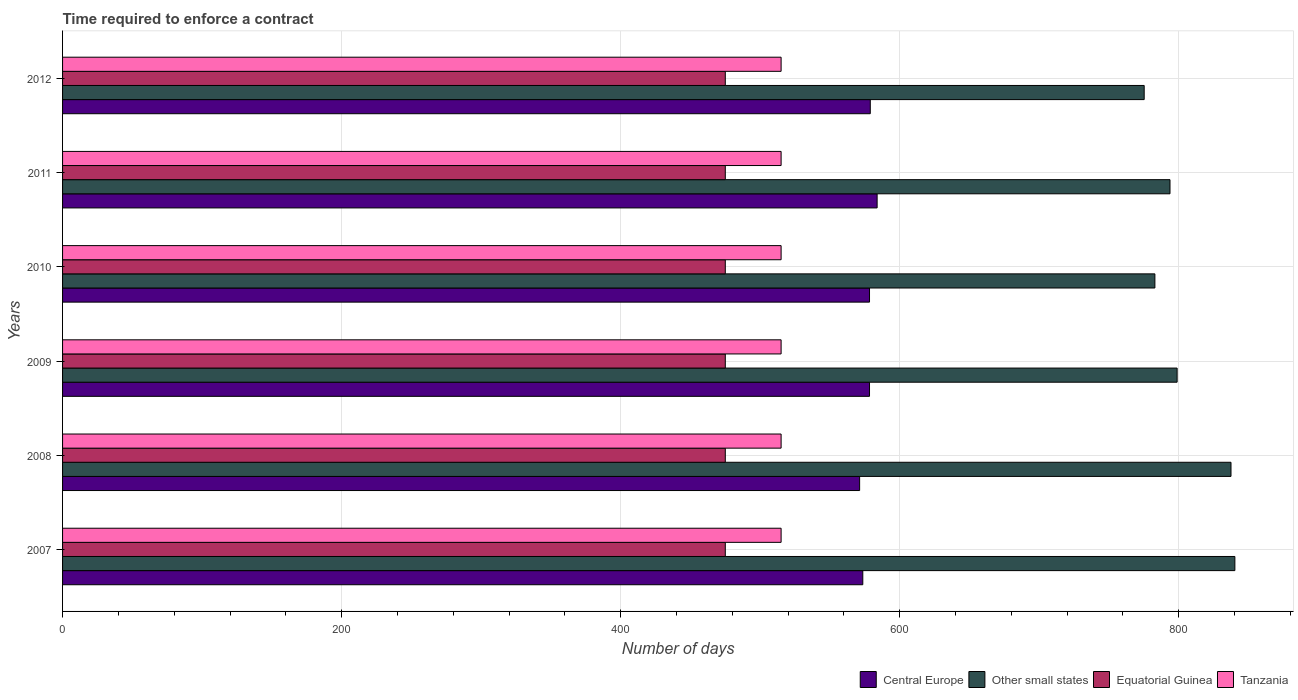How many bars are there on the 2nd tick from the bottom?
Your answer should be compact. 4. In how many cases, is the number of bars for a given year not equal to the number of legend labels?
Your answer should be compact. 0. What is the number of days required to enforce a contract in Central Europe in 2009?
Offer a terse response. 578.36. Across all years, what is the maximum number of days required to enforce a contract in Central Europe?
Provide a short and direct response. 583.82. Across all years, what is the minimum number of days required to enforce a contract in Other small states?
Offer a terse response. 775.22. What is the total number of days required to enforce a contract in Central Europe in the graph?
Your answer should be very brief. 3464.27. What is the difference between the number of days required to enforce a contract in Tanzania in 2009 and that in 2010?
Offer a terse response. 0. What is the difference between the number of days required to enforce a contract in Central Europe in 2010 and the number of days required to enforce a contract in Other small states in 2007?
Make the answer very short. -261.86. What is the average number of days required to enforce a contract in Central Europe per year?
Ensure brevity in your answer.  577.38. In the year 2009, what is the difference between the number of days required to enforce a contract in Central Europe and number of days required to enforce a contract in Equatorial Guinea?
Offer a very short reply. 103.36. In how many years, is the number of days required to enforce a contract in Central Europe greater than 520 days?
Give a very brief answer. 6. What is the ratio of the number of days required to enforce a contract in Other small states in 2007 to that in 2011?
Provide a succinct answer. 1.06. Is the number of days required to enforce a contract in Central Europe in 2008 less than that in 2012?
Keep it short and to the point. Yes. Is the difference between the number of days required to enforce a contract in Central Europe in 2011 and 2012 greater than the difference between the number of days required to enforce a contract in Equatorial Guinea in 2011 and 2012?
Provide a short and direct response. Yes. In how many years, is the number of days required to enforce a contract in Central Europe greater than the average number of days required to enforce a contract in Central Europe taken over all years?
Give a very brief answer. 4. What does the 1st bar from the top in 2009 represents?
Offer a very short reply. Tanzania. What does the 1st bar from the bottom in 2008 represents?
Make the answer very short. Central Europe. Is it the case that in every year, the sum of the number of days required to enforce a contract in Tanzania and number of days required to enforce a contract in Other small states is greater than the number of days required to enforce a contract in Central Europe?
Keep it short and to the point. Yes. How many bars are there?
Keep it short and to the point. 24. How many years are there in the graph?
Your answer should be compact. 6. Are the values on the major ticks of X-axis written in scientific E-notation?
Ensure brevity in your answer.  No. Does the graph contain grids?
Your answer should be compact. Yes. How many legend labels are there?
Provide a short and direct response. 4. What is the title of the graph?
Your response must be concise. Time required to enforce a contract. What is the label or title of the X-axis?
Provide a succinct answer. Number of days. What is the Number of days of Central Europe in 2007?
Keep it short and to the point. 573.55. What is the Number of days of Other small states in 2007?
Offer a terse response. 840.22. What is the Number of days of Equatorial Guinea in 2007?
Your answer should be compact. 475. What is the Number of days of Tanzania in 2007?
Provide a short and direct response. 515. What is the Number of days in Central Europe in 2008?
Ensure brevity in your answer.  571.27. What is the Number of days in Other small states in 2008?
Offer a very short reply. 837.44. What is the Number of days of Equatorial Guinea in 2008?
Make the answer very short. 475. What is the Number of days in Tanzania in 2008?
Provide a succinct answer. 515. What is the Number of days of Central Europe in 2009?
Ensure brevity in your answer.  578.36. What is the Number of days in Other small states in 2009?
Offer a very short reply. 798.83. What is the Number of days in Equatorial Guinea in 2009?
Your answer should be very brief. 475. What is the Number of days of Tanzania in 2009?
Your response must be concise. 515. What is the Number of days in Central Europe in 2010?
Ensure brevity in your answer.  578.36. What is the Number of days of Other small states in 2010?
Your answer should be very brief. 782.89. What is the Number of days of Equatorial Guinea in 2010?
Your answer should be compact. 475. What is the Number of days in Tanzania in 2010?
Your response must be concise. 515. What is the Number of days in Central Europe in 2011?
Make the answer very short. 583.82. What is the Number of days of Other small states in 2011?
Your answer should be very brief. 793.72. What is the Number of days in Equatorial Guinea in 2011?
Provide a succinct answer. 475. What is the Number of days of Tanzania in 2011?
Offer a terse response. 515. What is the Number of days of Central Europe in 2012?
Offer a terse response. 578.91. What is the Number of days of Other small states in 2012?
Keep it short and to the point. 775.22. What is the Number of days of Equatorial Guinea in 2012?
Provide a succinct answer. 475. What is the Number of days in Tanzania in 2012?
Your response must be concise. 515. Across all years, what is the maximum Number of days in Central Europe?
Your response must be concise. 583.82. Across all years, what is the maximum Number of days of Other small states?
Give a very brief answer. 840.22. Across all years, what is the maximum Number of days in Equatorial Guinea?
Offer a terse response. 475. Across all years, what is the maximum Number of days of Tanzania?
Offer a terse response. 515. Across all years, what is the minimum Number of days in Central Europe?
Ensure brevity in your answer.  571.27. Across all years, what is the minimum Number of days in Other small states?
Your response must be concise. 775.22. Across all years, what is the minimum Number of days of Equatorial Guinea?
Provide a succinct answer. 475. Across all years, what is the minimum Number of days in Tanzania?
Give a very brief answer. 515. What is the total Number of days in Central Europe in the graph?
Ensure brevity in your answer.  3464.27. What is the total Number of days of Other small states in the graph?
Your answer should be compact. 4828.33. What is the total Number of days of Equatorial Guinea in the graph?
Provide a short and direct response. 2850. What is the total Number of days in Tanzania in the graph?
Provide a succinct answer. 3090. What is the difference between the Number of days in Central Europe in 2007 and that in 2008?
Provide a short and direct response. 2.27. What is the difference between the Number of days in Other small states in 2007 and that in 2008?
Give a very brief answer. 2.78. What is the difference between the Number of days in Equatorial Guinea in 2007 and that in 2008?
Offer a terse response. 0. What is the difference between the Number of days in Central Europe in 2007 and that in 2009?
Provide a short and direct response. -4.82. What is the difference between the Number of days of Other small states in 2007 and that in 2009?
Offer a terse response. 41.39. What is the difference between the Number of days of Central Europe in 2007 and that in 2010?
Ensure brevity in your answer.  -4.82. What is the difference between the Number of days of Other small states in 2007 and that in 2010?
Give a very brief answer. 57.33. What is the difference between the Number of days of Equatorial Guinea in 2007 and that in 2010?
Your response must be concise. 0. What is the difference between the Number of days of Central Europe in 2007 and that in 2011?
Offer a very short reply. -10.27. What is the difference between the Number of days in Other small states in 2007 and that in 2011?
Your answer should be compact. 46.5. What is the difference between the Number of days of Equatorial Guinea in 2007 and that in 2011?
Your answer should be compact. 0. What is the difference between the Number of days in Tanzania in 2007 and that in 2011?
Offer a very short reply. 0. What is the difference between the Number of days in Central Europe in 2007 and that in 2012?
Make the answer very short. -5.36. What is the difference between the Number of days of Tanzania in 2007 and that in 2012?
Give a very brief answer. 0. What is the difference between the Number of days in Central Europe in 2008 and that in 2009?
Provide a succinct answer. -7.09. What is the difference between the Number of days in Other small states in 2008 and that in 2009?
Ensure brevity in your answer.  38.61. What is the difference between the Number of days of Equatorial Guinea in 2008 and that in 2009?
Keep it short and to the point. 0. What is the difference between the Number of days in Central Europe in 2008 and that in 2010?
Keep it short and to the point. -7.09. What is the difference between the Number of days in Other small states in 2008 and that in 2010?
Provide a short and direct response. 54.56. What is the difference between the Number of days of Central Europe in 2008 and that in 2011?
Provide a succinct answer. -12.55. What is the difference between the Number of days of Other small states in 2008 and that in 2011?
Your answer should be compact. 43.72. What is the difference between the Number of days of Central Europe in 2008 and that in 2012?
Your answer should be compact. -7.64. What is the difference between the Number of days in Other small states in 2008 and that in 2012?
Your answer should be very brief. 62.22. What is the difference between the Number of days of Tanzania in 2008 and that in 2012?
Your answer should be very brief. 0. What is the difference between the Number of days in Other small states in 2009 and that in 2010?
Your answer should be compact. 15.94. What is the difference between the Number of days in Tanzania in 2009 and that in 2010?
Make the answer very short. 0. What is the difference between the Number of days in Central Europe in 2009 and that in 2011?
Your response must be concise. -5.45. What is the difference between the Number of days of Other small states in 2009 and that in 2011?
Keep it short and to the point. 5.11. What is the difference between the Number of days of Tanzania in 2009 and that in 2011?
Keep it short and to the point. 0. What is the difference between the Number of days in Central Europe in 2009 and that in 2012?
Provide a short and direct response. -0.55. What is the difference between the Number of days of Other small states in 2009 and that in 2012?
Your answer should be very brief. 23.61. What is the difference between the Number of days in Central Europe in 2010 and that in 2011?
Your answer should be compact. -5.45. What is the difference between the Number of days of Other small states in 2010 and that in 2011?
Make the answer very short. -10.83. What is the difference between the Number of days in Tanzania in 2010 and that in 2011?
Offer a very short reply. 0. What is the difference between the Number of days in Central Europe in 2010 and that in 2012?
Provide a short and direct response. -0.55. What is the difference between the Number of days of Other small states in 2010 and that in 2012?
Ensure brevity in your answer.  7.67. What is the difference between the Number of days of Equatorial Guinea in 2010 and that in 2012?
Your answer should be compact. 0. What is the difference between the Number of days of Central Europe in 2011 and that in 2012?
Keep it short and to the point. 4.91. What is the difference between the Number of days of Central Europe in 2007 and the Number of days of Other small states in 2008?
Give a very brief answer. -263.9. What is the difference between the Number of days of Central Europe in 2007 and the Number of days of Equatorial Guinea in 2008?
Make the answer very short. 98.55. What is the difference between the Number of days in Central Europe in 2007 and the Number of days in Tanzania in 2008?
Give a very brief answer. 58.55. What is the difference between the Number of days in Other small states in 2007 and the Number of days in Equatorial Guinea in 2008?
Provide a short and direct response. 365.22. What is the difference between the Number of days in Other small states in 2007 and the Number of days in Tanzania in 2008?
Your answer should be compact. 325.22. What is the difference between the Number of days in Central Europe in 2007 and the Number of days in Other small states in 2009?
Give a very brief answer. -225.29. What is the difference between the Number of days of Central Europe in 2007 and the Number of days of Equatorial Guinea in 2009?
Your answer should be very brief. 98.55. What is the difference between the Number of days of Central Europe in 2007 and the Number of days of Tanzania in 2009?
Provide a succinct answer. 58.55. What is the difference between the Number of days of Other small states in 2007 and the Number of days of Equatorial Guinea in 2009?
Your answer should be compact. 365.22. What is the difference between the Number of days of Other small states in 2007 and the Number of days of Tanzania in 2009?
Offer a terse response. 325.22. What is the difference between the Number of days of Equatorial Guinea in 2007 and the Number of days of Tanzania in 2009?
Ensure brevity in your answer.  -40. What is the difference between the Number of days in Central Europe in 2007 and the Number of days in Other small states in 2010?
Keep it short and to the point. -209.34. What is the difference between the Number of days of Central Europe in 2007 and the Number of days of Equatorial Guinea in 2010?
Offer a very short reply. 98.55. What is the difference between the Number of days of Central Europe in 2007 and the Number of days of Tanzania in 2010?
Offer a terse response. 58.55. What is the difference between the Number of days in Other small states in 2007 and the Number of days in Equatorial Guinea in 2010?
Your response must be concise. 365.22. What is the difference between the Number of days in Other small states in 2007 and the Number of days in Tanzania in 2010?
Your answer should be very brief. 325.22. What is the difference between the Number of days in Central Europe in 2007 and the Number of days in Other small states in 2011?
Offer a terse response. -220.18. What is the difference between the Number of days in Central Europe in 2007 and the Number of days in Equatorial Guinea in 2011?
Provide a succinct answer. 98.55. What is the difference between the Number of days of Central Europe in 2007 and the Number of days of Tanzania in 2011?
Give a very brief answer. 58.55. What is the difference between the Number of days in Other small states in 2007 and the Number of days in Equatorial Guinea in 2011?
Offer a very short reply. 365.22. What is the difference between the Number of days of Other small states in 2007 and the Number of days of Tanzania in 2011?
Keep it short and to the point. 325.22. What is the difference between the Number of days in Equatorial Guinea in 2007 and the Number of days in Tanzania in 2011?
Give a very brief answer. -40. What is the difference between the Number of days of Central Europe in 2007 and the Number of days of Other small states in 2012?
Provide a succinct answer. -201.68. What is the difference between the Number of days in Central Europe in 2007 and the Number of days in Equatorial Guinea in 2012?
Give a very brief answer. 98.55. What is the difference between the Number of days in Central Europe in 2007 and the Number of days in Tanzania in 2012?
Your answer should be compact. 58.55. What is the difference between the Number of days in Other small states in 2007 and the Number of days in Equatorial Guinea in 2012?
Keep it short and to the point. 365.22. What is the difference between the Number of days in Other small states in 2007 and the Number of days in Tanzania in 2012?
Keep it short and to the point. 325.22. What is the difference between the Number of days of Equatorial Guinea in 2007 and the Number of days of Tanzania in 2012?
Provide a short and direct response. -40. What is the difference between the Number of days of Central Europe in 2008 and the Number of days of Other small states in 2009?
Give a very brief answer. -227.56. What is the difference between the Number of days of Central Europe in 2008 and the Number of days of Equatorial Guinea in 2009?
Give a very brief answer. 96.27. What is the difference between the Number of days in Central Europe in 2008 and the Number of days in Tanzania in 2009?
Provide a short and direct response. 56.27. What is the difference between the Number of days in Other small states in 2008 and the Number of days in Equatorial Guinea in 2009?
Ensure brevity in your answer.  362.44. What is the difference between the Number of days in Other small states in 2008 and the Number of days in Tanzania in 2009?
Your answer should be very brief. 322.44. What is the difference between the Number of days in Equatorial Guinea in 2008 and the Number of days in Tanzania in 2009?
Your answer should be compact. -40. What is the difference between the Number of days in Central Europe in 2008 and the Number of days in Other small states in 2010?
Keep it short and to the point. -211.62. What is the difference between the Number of days in Central Europe in 2008 and the Number of days in Equatorial Guinea in 2010?
Offer a very short reply. 96.27. What is the difference between the Number of days in Central Europe in 2008 and the Number of days in Tanzania in 2010?
Keep it short and to the point. 56.27. What is the difference between the Number of days in Other small states in 2008 and the Number of days in Equatorial Guinea in 2010?
Give a very brief answer. 362.44. What is the difference between the Number of days of Other small states in 2008 and the Number of days of Tanzania in 2010?
Ensure brevity in your answer.  322.44. What is the difference between the Number of days of Central Europe in 2008 and the Number of days of Other small states in 2011?
Make the answer very short. -222.45. What is the difference between the Number of days of Central Europe in 2008 and the Number of days of Equatorial Guinea in 2011?
Ensure brevity in your answer.  96.27. What is the difference between the Number of days of Central Europe in 2008 and the Number of days of Tanzania in 2011?
Ensure brevity in your answer.  56.27. What is the difference between the Number of days of Other small states in 2008 and the Number of days of Equatorial Guinea in 2011?
Keep it short and to the point. 362.44. What is the difference between the Number of days in Other small states in 2008 and the Number of days in Tanzania in 2011?
Ensure brevity in your answer.  322.44. What is the difference between the Number of days of Equatorial Guinea in 2008 and the Number of days of Tanzania in 2011?
Your answer should be compact. -40. What is the difference between the Number of days of Central Europe in 2008 and the Number of days of Other small states in 2012?
Your answer should be very brief. -203.95. What is the difference between the Number of days of Central Europe in 2008 and the Number of days of Equatorial Guinea in 2012?
Give a very brief answer. 96.27. What is the difference between the Number of days in Central Europe in 2008 and the Number of days in Tanzania in 2012?
Make the answer very short. 56.27. What is the difference between the Number of days of Other small states in 2008 and the Number of days of Equatorial Guinea in 2012?
Your answer should be compact. 362.44. What is the difference between the Number of days of Other small states in 2008 and the Number of days of Tanzania in 2012?
Give a very brief answer. 322.44. What is the difference between the Number of days of Central Europe in 2009 and the Number of days of Other small states in 2010?
Keep it short and to the point. -204.53. What is the difference between the Number of days of Central Europe in 2009 and the Number of days of Equatorial Guinea in 2010?
Make the answer very short. 103.36. What is the difference between the Number of days in Central Europe in 2009 and the Number of days in Tanzania in 2010?
Provide a succinct answer. 63.36. What is the difference between the Number of days in Other small states in 2009 and the Number of days in Equatorial Guinea in 2010?
Give a very brief answer. 323.83. What is the difference between the Number of days in Other small states in 2009 and the Number of days in Tanzania in 2010?
Offer a terse response. 283.83. What is the difference between the Number of days in Central Europe in 2009 and the Number of days in Other small states in 2011?
Offer a very short reply. -215.36. What is the difference between the Number of days of Central Europe in 2009 and the Number of days of Equatorial Guinea in 2011?
Make the answer very short. 103.36. What is the difference between the Number of days in Central Europe in 2009 and the Number of days in Tanzania in 2011?
Your answer should be very brief. 63.36. What is the difference between the Number of days of Other small states in 2009 and the Number of days of Equatorial Guinea in 2011?
Keep it short and to the point. 323.83. What is the difference between the Number of days in Other small states in 2009 and the Number of days in Tanzania in 2011?
Keep it short and to the point. 283.83. What is the difference between the Number of days of Equatorial Guinea in 2009 and the Number of days of Tanzania in 2011?
Offer a terse response. -40. What is the difference between the Number of days in Central Europe in 2009 and the Number of days in Other small states in 2012?
Provide a short and direct response. -196.86. What is the difference between the Number of days in Central Europe in 2009 and the Number of days in Equatorial Guinea in 2012?
Provide a succinct answer. 103.36. What is the difference between the Number of days of Central Europe in 2009 and the Number of days of Tanzania in 2012?
Offer a terse response. 63.36. What is the difference between the Number of days in Other small states in 2009 and the Number of days in Equatorial Guinea in 2012?
Provide a short and direct response. 323.83. What is the difference between the Number of days of Other small states in 2009 and the Number of days of Tanzania in 2012?
Provide a short and direct response. 283.83. What is the difference between the Number of days of Equatorial Guinea in 2009 and the Number of days of Tanzania in 2012?
Your answer should be compact. -40. What is the difference between the Number of days of Central Europe in 2010 and the Number of days of Other small states in 2011?
Your answer should be very brief. -215.36. What is the difference between the Number of days of Central Europe in 2010 and the Number of days of Equatorial Guinea in 2011?
Your answer should be very brief. 103.36. What is the difference between the Number of days in Central Europe in 2010 and the Number of days in Tanzania in 2011?
Offer a terse response. 63.36. What is the difference between the Number of days in Other small states in 2010 and the Number of days in Equatorial Guinea in 2011?
Offer a very short reply. 307.89. What is the difference between the Number of days in Other small states in 2010 and the Number of days in Tanzania in 2011?
Offer a terse response. 267.89. What is the difference between the Number of days in Central Europe in 2010 and the Number of days in Other small states in 2012?
Offer a very short reply. -196.86. What is the difference between the Number of days in Central Europe in 2010 and the Number of days in Equatorial Guinea in 2012?
Give a very brief answer. 103.36. What is the difference between the Number of days of Central Europe in 2010 and the Number of days of Tanzania in 2012?
Ensure brevity in your answer.  63.36. What is the difference between the Number of days in Other small states in 2010 and the Number of days in Equatorial Guinea in 2012?
Your answer should be compact. 307.89. What is the difference between the Number of days of Other small states in 2010 and the Number of days of Tanzania in 2012?
Ensure brevity in your answer.  267.89. What is the difference between the Number of days in Equatorial Guinea in 2010 and the Number of days in Tanzania in 2012?
Offer a terse response. -40. What is the difference between the Number of days of Central Europe in 2011 and the Number of days of Other small states in 2012?
Make the answer very short. -191.4. What is the difference between the Number of days of Central Europe in 2011 and the Number of days of Equatorial Guinea in 2012?
Provide a succinct answer. 108.82. What is the difference between the Number of days of Central Europe in 2011 and the Number of days of Tanzania in 2012?
Keep it short and to the point. 68.82. What is the difference between the Number of days in Other small states in 2011 and the Number of days in Equatorial Guinea in 2012?
Keep it short and to the point. 318.72. What is the difference between the Number of days in Other small states in 2011 and the Number of days in Tanzania in 2012?
Offer a terse response. 278.72. What is the difference between the Number of days of Equatorial Guinea in 2011 and the Number of days of Tanzania in 2012?
Make the answer very short. -40. What is the average Number of days of Central Europe per year?
Provide a succinct answer. 577.38. What is the average Number of days of Other small states per year?
Ensure brevity in your answer.  804.72. What is the average Number of days of Equatorial Guinea per year?
Offer a very short reply. 475. What is the average Number of days of Tanzania per year?
Your response must be concise. 515. In the year 2007, what is the difference between the Number of days in Central Europe and Number of days in Other small states?
Provide a short and direct response. -266.68. In the year 2007, what is the difference between the Number of days in Central Europe and Number of days in Equatorial Guinea?
Your answer should be compact. 98.55. In the year 2007, what is the difference between the Number of days of Central Europe and Number of days of Tanzania?
Offer a very short reply. 58.55. In the year 2007, what is the difference between the Number of days in Other small states and Number of days in Equatorial Guinea?
Provide a short and direct response. 365.22. In the year 2007, what is the difference between the Number of days of Other small states and Number of days of Tanzania?
Your response must be concise. 325.22. In the year 2008, what is the difference between the Number of days of Central Europe and Number of days of Other small states?
Give a very brief answer. -266.17. In the year 2008, what is the difference between the Number of days in Central Europe and Number of days in Equatorial Guinea?
Your response must be concise. 96.27. In the year 2008, what is the difference between the Number of days in Central Europe and Number of days in Tanzania?
Provide a succinct answer. 56.27. In the year 2008, what is the difference between the Number of days of Other small states and Number of days of Equatorial Guinea?
Your response must be concise. 362.44. In the year 2008, what is the difference between the Number of days of Other small states and Number of days of Tanzania?
Ensure brevity in your answer.  322.44. In the year 2009, what is the difference between the Number of days of Central Europe and Number of days of Other small states?
Keep it short and to the point. -220.47. In the year 2009, what is the difference between the Number of days of Central Europe and Number of days of Equatorial Guinea?
Your response must be concise. 103.36. In the year 2009, what is the difference between the Number of days of Central Europe and Number of days of Tanzania?
Make the answer very short. 63.36. In the year 2009, what is the difference between the Number of days of Other small states and Number of days of Equatorial Guinea?
Offer a very short reply. 323.83. In the year 2009, what is the difference between the Number of days of Other small states and Number of days of Tanzania?
Provide a succinct answer. 283.83. In the year 2010, what is the difference between the Number of days of Central Europe and Number of days of Other small states?
Ensure brevity in your answer.  -204.53. In the year 2010, what is the difference between the Number of days of Central Europe and Number of days of Equatorial Guinea?
Ensure brevity in your answer.  103.36. In the year 2010, what is the difference between the Number of days of Central Europe and Number of days of Tanzania?
Offer a terse response. 63.36. In the year 2010, what is the difference between the Number of days in Other small states and Number of days in Equatorial Guinea?
Offer a terse response. 307.89. In the year 2010, what is the difference between the Number of days in Other small states and Number of days in Tanzania?
Offer a terse response. 267.89. In the year 2011, what is the difference between the Number of days of Central Europe and Number of days of Other small states?
Keep it short and to the point. -209.9. In the year 2011, what is the difference between the Number of days in Central Europe and Number of days in Equatorial Guinea?
Your answer should be compact. 108.82. In the year 2011, what is the difference between the Number of days of Central Europe and Number of days of Tanzania?
Your answer should be very brief. 68.82. In the year 2011, what is the difference between the Number of days in Other small states and Number of days in Equatorial Guinea?
Provide a succinct answer. 318.72. In the year 2011, what is the difference between the Number of days in Other small states and Number of days in Tanzania?
Offer a very short reply. 278.72. In the year 2011, what is the difference between the Number of days of Equatorial Guinea and Number of days of Tanzania?
Keep it short and to the point. -40. In the year 2012, what is the difference between the Number of days in Central Europe and Number of days in Other small states?
Offer a terse response. -196.31. In the year 2012, what is the difference between the Number of days in Central Europe and Number of days in Equatorial Guinea?
Offer a very short reply. 103.91. In the year 2012, what is the difference between the Number of days of Central Europe and Number of days of Tanzania?
Ensure brevity in your answer.  63.91. In the year 2012, what is the difference between the Number of days of Other small states and Number of days of Equatorial Guinea?
Ensure brevity in your answer.  300.22. In the year 2012, what is the difference between the Number of days of Other small states and Number of days of Tanzania?
Offer a very short reply. 260.22. What is the ratio of the Number of days of Central Europe in 2007 to that in 2008?
Give a very brief answer. 1. What is the ratio of the Number of days in Equatorial Guinea in 2007 to that in 2008?
Offer a very short reply. 1. What is the ratio of the Number of days of Other small states in 2007 to that in 2009?
Your answer should be very brief. 1.05. What is the ratio of the Number of days in Tanzania in 2007 to that in 2009?
Ensure brevity in your answer.  1. What is the ratio of the Number of days in Other small states in 2007 to that in 2010?
Offer a terse response. 1.07. What is the ratio of the Number of days in Tanzania in 2007 to that in 2010?
Your answer should be very brief. 1. What is the ratio of the Number of days of Central Europe in 2007 to that in 2011?
Your response must be concise. 0.98. What is the ratio of the Number of days of Other small states in 2007 to that in 2011?
Your response must be concise. 1.06. What is the ratio of the Number of days in Equatorial Guinea in 2007 to that in 2011?
Your response must be concise. 1. What is the ratio of the Number of days of Tanzania in 2007 to that in 2011?
Provide a succinct answer. 1. What is the ratio of the Number of days of Central Europe in 2007 to that in 2012?
Offer a terse response. 0.99. What is the ratio of the Number of days in Other small states in 2007 to that in 2012?
Provide a short and direct response. 1.08. What is the ratio of the Number of days in Equatorial Guinea in 2007 to that in 2012?
Your response must be concise. 1. What is the ratio of the Number of days in Tanzania in 2007 to that in 2012?
Provide a succinct answer. 1. What is the ratio of the Number of days in Central Europe in 2008 to that in 2009?
Offer a very short reply. 0.99. What is the ratio of the Number of days of Other small states in 2008 to that in 2009?
Provide a succinct answer. 1.05. What is the ratio of the Number of days of Equatorial Guinea in 2008 to that in 2009?
Provide a short and direct response. 1. What is the ratio of the Number of days in Tanzania in 2008 to that in 2009?
Provide a short and direct response. 1. What is the ratio of the Number of days in Central Europe in 2008 to that in 2010?
Your answer should be compact. 0.99. What is the ratio of the Number of days of Other small states in 2008 to that in 2010?
Ensure brevity in your answer.  1.07. What is the ratio of the Number of days of Central Europe in 2008 to that in 2011?
Your response must be concise. 0.98. What is the ratio of the Number of days in Other small states in 2008 to that in 2011?
Give a very brief answer. 1.06. What is the ratio of the Number of days in Other small states in 2008 to that in 2012?
Offer a terse response. 1.08. What is the ratio of the Number of days in Equatorial Guinea in 2008 to that in 2012?
Provide a succinct answer. 1. What is the ratio of the Number of days in Tanzania in 2008 to that in 2012?
Ensure brevity in your answer.  1. What is the ratio of the Number of days in Other small states in 2009 to that in 2010?
Provide a succinct answer. 1.02. What is the ratio of the Number of days in Other small states in 2009 to that in 2011?
Keep it short and to the point. 1.01. What is the ratio of the Number of days of Equatorial Guinea in 2009 to that in 2011?
Make the answer very short. 1. What is the ratio of the Number of days in Tanzania in 2009 to that in 2011?
Your answer should be compact. 1. What is the ratio of the Number of days in Other small states in 2009 to that in 2012?
Your answer should be compact. 1.03. What is the ratio of the Number of days in Equatorial Guinea in 2009 to that in 2012?
Provide a short and direct response. 1. What is the ratio of the Number of days of Tanzania in 2009 to that in 2012?
Give a very brief answer. 1. What is the ratio of the Number of days of Central Europe in 2010 to that in 2011?
Your answer should be very brief. 0.99. What is the ratio of the Number of days in Other small states in 2010 to that in 2011?
Your response must be concise. 0.99. What is the ratio of the Number of days of Equatorial Guinea in 2010 to that in 2011?
Provide a succinct answer. 1. What is the ratio of the Number of days in Tanzania in 2010 to that in 2011?
Offer a very short reply. 1. What is the ratio of the Number of days of Central Europe in 2010 to that in 2012?
Your answer should be very brief. 1. What is the ratio of the Number of days in Other small states in 2010 to that in 2012?
Provide a succinct answer. 1.01. What is the ratio of the Number of days in Tanzania in 2010 to that in 2012?
Ensure brevity in your answer.  1. What is the ratio of the Number of days in Central Europe in 2011 to that in 2012?
Your answer should be compact. 1.01. What is the ratio of the Number of days in Other small states in 2011 to that in 2012?
Your answer should be very brief. 1.02. What is the ratio of the Number of days in Equatorial Guinea in 2011 to that in 2012?
Provide a short and direct response. 1. What is the ratio of the Number of days in Tanzania in 2011 to that in 2012?
Ensure brevity in your answer.  1. What is the difference between the highest and the second highest Number of days in Central Europe?
Ensure brevity in your answer.  4.91. What is the difference between the highest and the second highest Number of days of Other small states?
Your answer should be compact. 2.78. What is the difference between the highest and the lowest Number of days in Central Europe?
Your answer should be compact. 12.55. What is the difference between the highest and the lowest Number of days in Equatorial Guinea?
Provide a short and direct response. 0. 